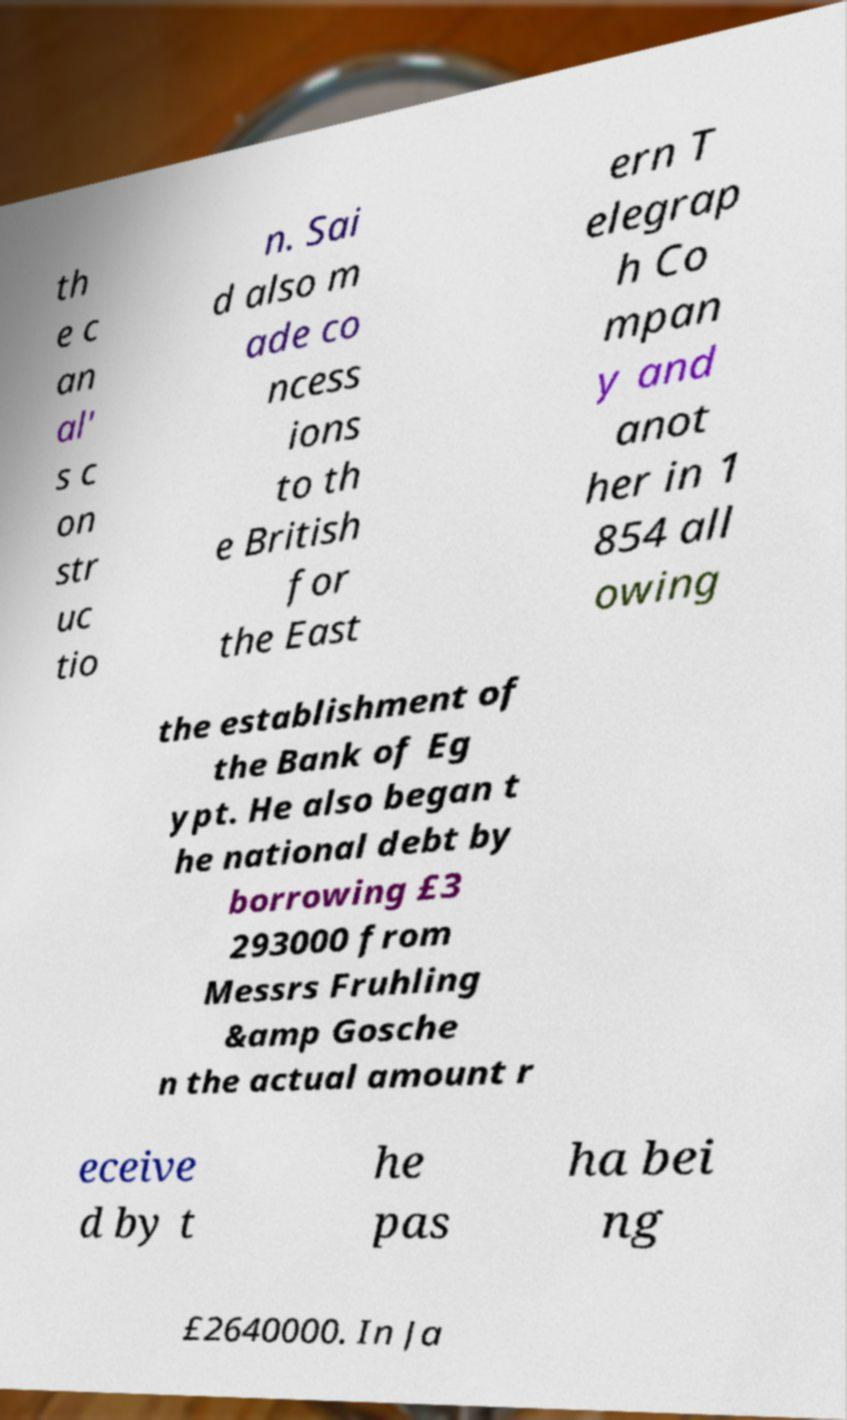Can you accurately transcribe the text from the provided image for me? th e c an al' s c on str uc tio n. Sai d also m ade co ncess ions to th e British for the East ern T elegrap h Co mpan y and anot her in 1 854 all owing the establishment of the Bank of Eg ypt. He also began t he national debt by borrowing £3 293000 from Messrs Fruhling &amp Gosche n the actual amount r eceive d by t he pas ha bei ng £2640000. In Ja 